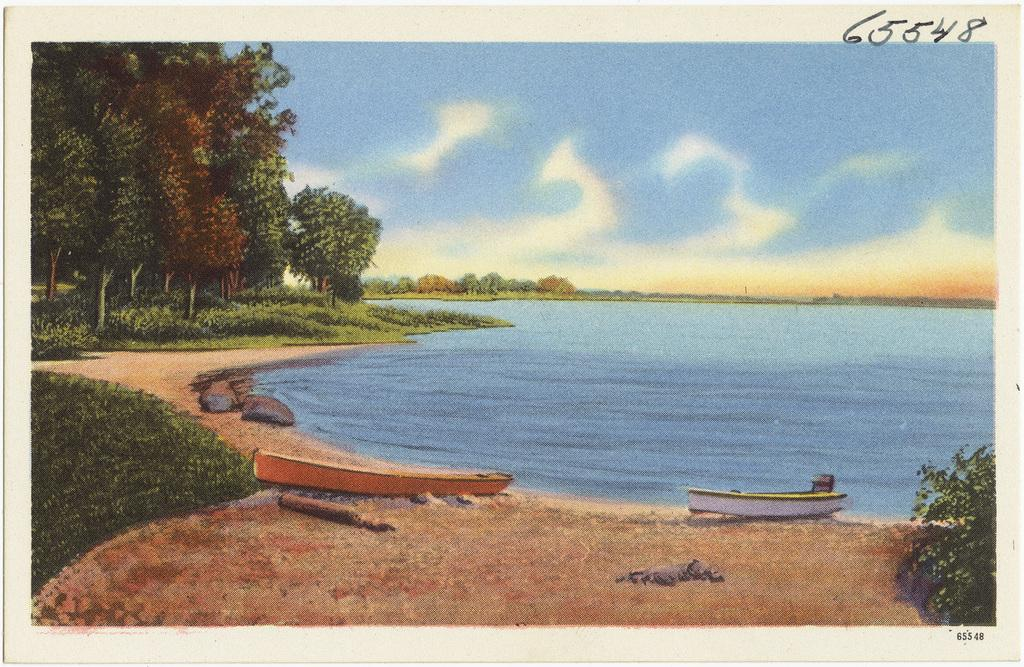What type of visual representation is the image? The image is a poster. What is depicted in the foreground of the image? There is water in the image, and two boats are in the water. What can be seen in the background of the image? There are trees, grass, stones, and clouds in the sky in the background of the image. What type of wool is being used to make the crib in the image? There is no crib present in the image, and therefore no wool can be associated with it. 